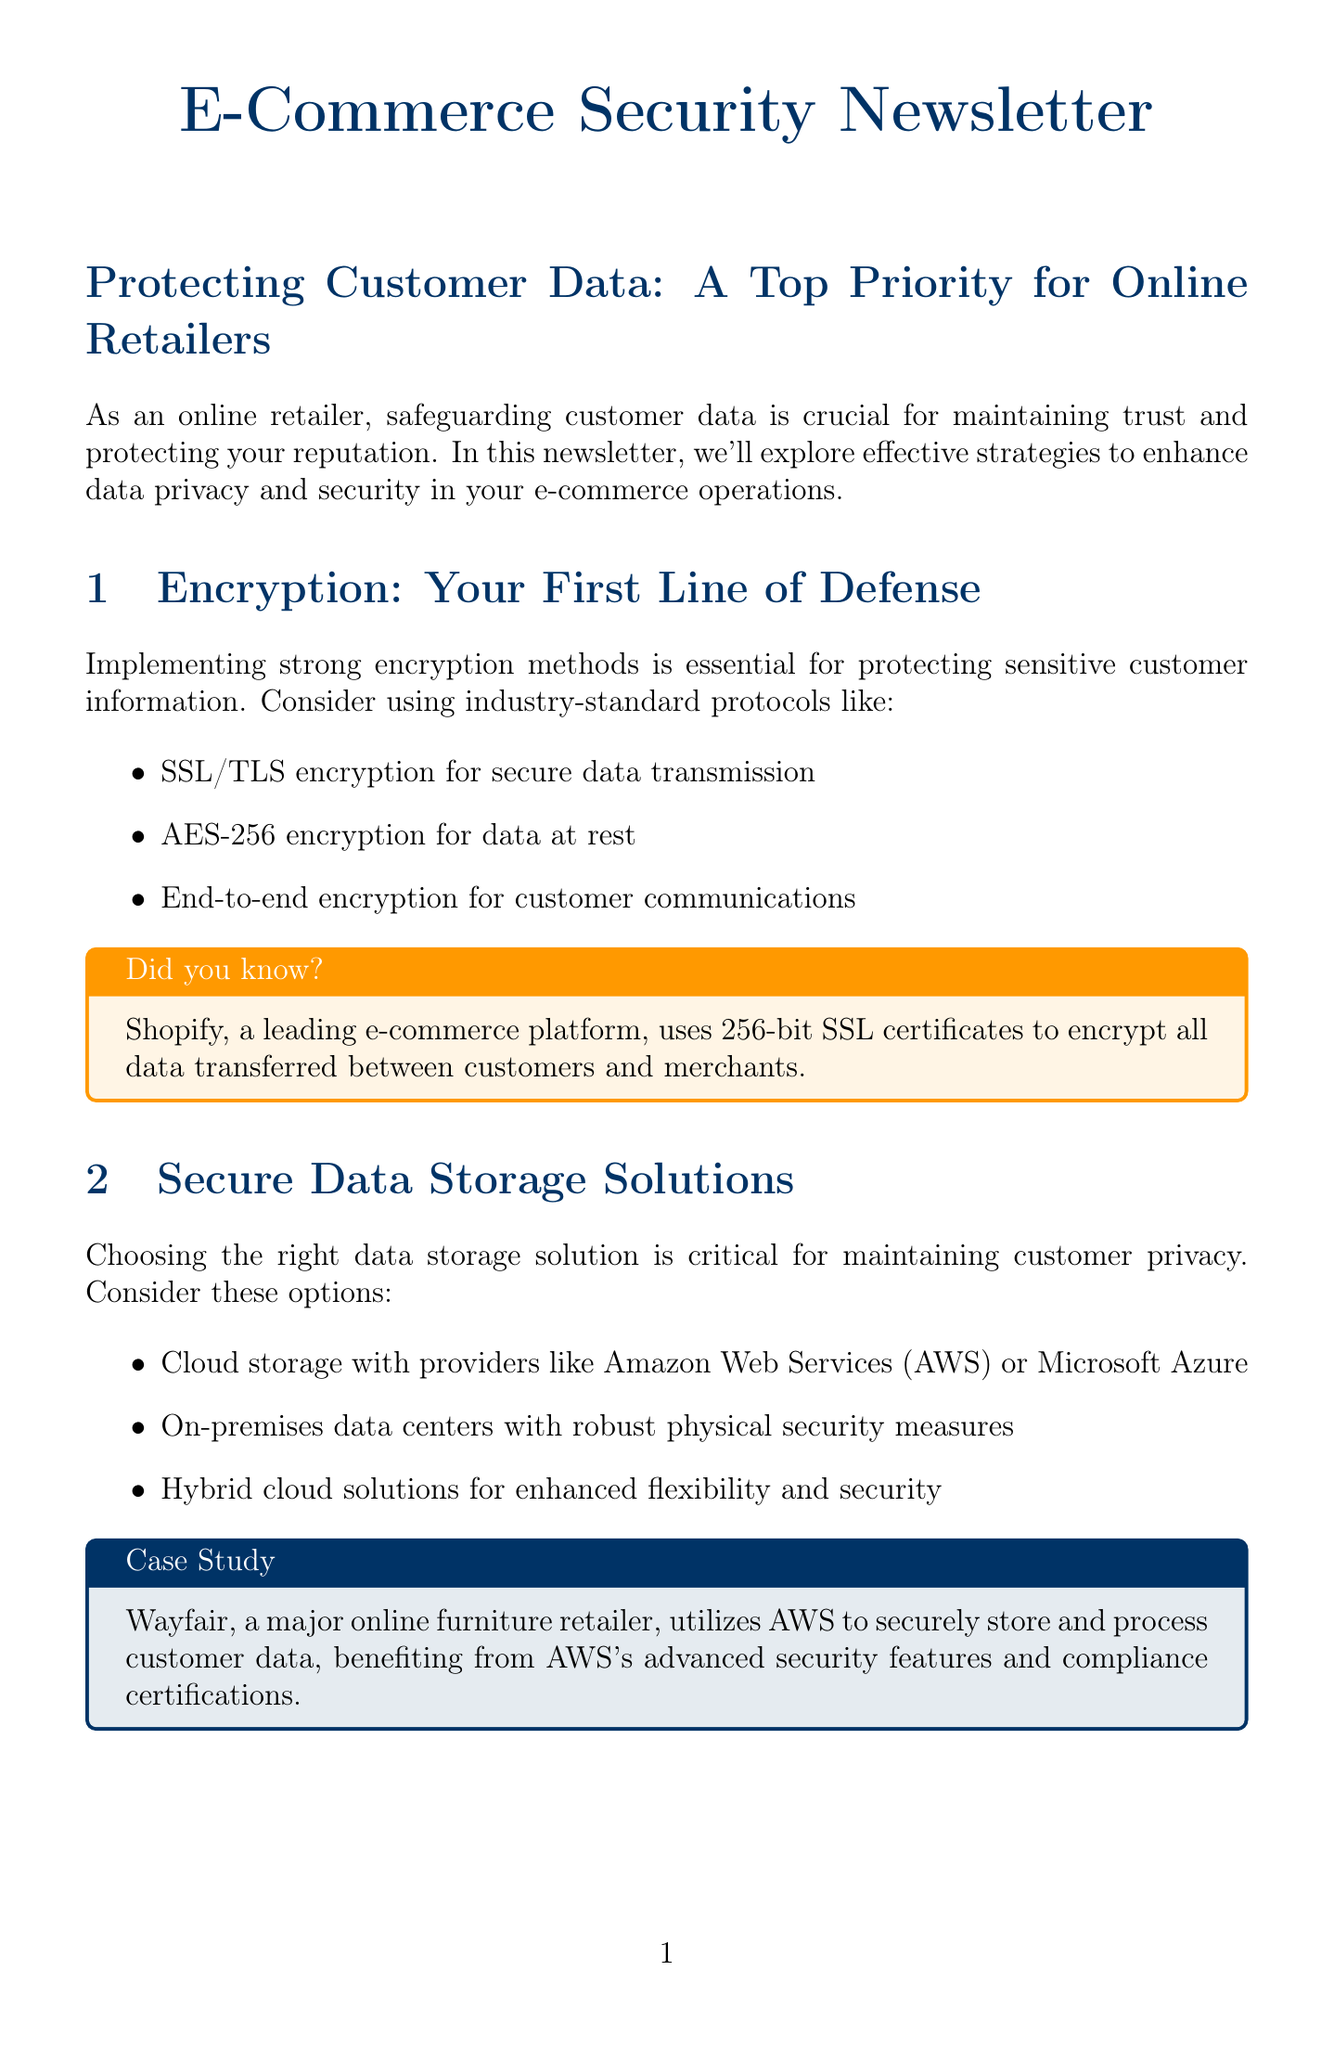What is the main focus of the newsletter? The main focus of the newsletter is safeguarding customer data, which is crucial for maintaining trust and protecting reputation.
Answer: safeguarding customer data What encryption method is recommended for secure data transmission? The document recommends SSL/TLS encryption for secure data transmission.
Answer: SSL/TLS encryption Which encryption standard is suggested for data at rest? The newsletter suggests using AES-256 encryption for data at rest.
Answer: AES-256 encryption What are some secure data storage solutions mentioned? The document mentions cloud storage with providers like AWS or Microsoft Azure as a secure solution.
Answer: cloud storage with providers like AWS or Microsoft Azure Which major online retailer utilizes AWS for data storage? The case study indicates that Wayfair utilizes AWS to securely store and process customer data.
Answer: Wayfair What compliance management tools are recommended? The document recommends using compliance management tools like OneTrust or TrustArc.
Answer: OneTrust or TrustArc What best practice involves updating software regularly? Regularly updating and patching all systems and software is a best practice mentioned in the newsletter.
Answer: Regularly update and patch all systems and software What type of security does Cloudflare provide? Cloudflare is mentioned as providing DDoS protection and web application firewall services.
Answer: DDoS protection and web application firewall How many main sections are there in the newsletter? There are seven main sections in the newsletter, not including the conclusion.
Answer: seven 